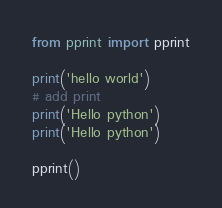Convert code to text. <code><loc_0><loc_0><loc_500><loc_500><_Python_>from pprint import pprint

print('hello world')
# add print
print('Hello python')
print('Hello python')

pprint()
</code> 